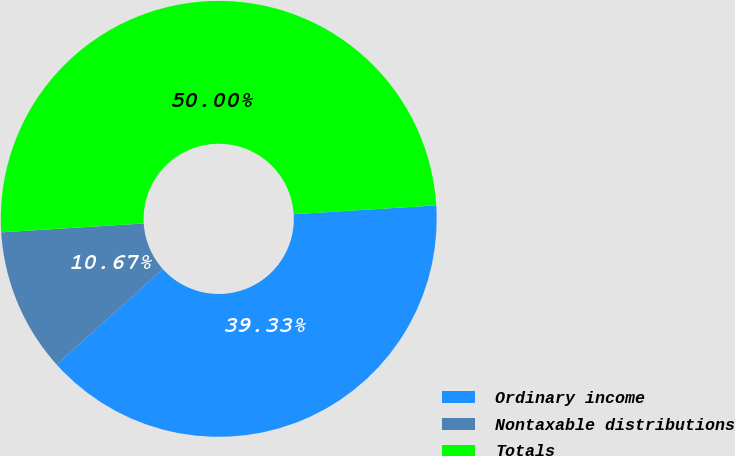<chart> <loc_0><loc_0><loc_500><loc_500><pie_chart><fcel>Ordinary income<fcel>Nontaxable distributions<fcel>Totals<nl><fcel>39.33%<fcel>10.67%<fcel>50.0%<nl></chart> 